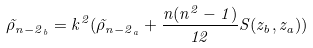<formula> <loc_0><loc_0><loc_500><loc_500>\tilde { \rho } _ { { n - 2 } _ { b } } = k ^ { 2 } ( \tilde { \rho } _ { { n - 2 } _ { a } } + \frac { n ( n ^ { 2 } - 1 ) } { 1 2 } S ( z _ { b } , z _ { a } ) )</formula> 